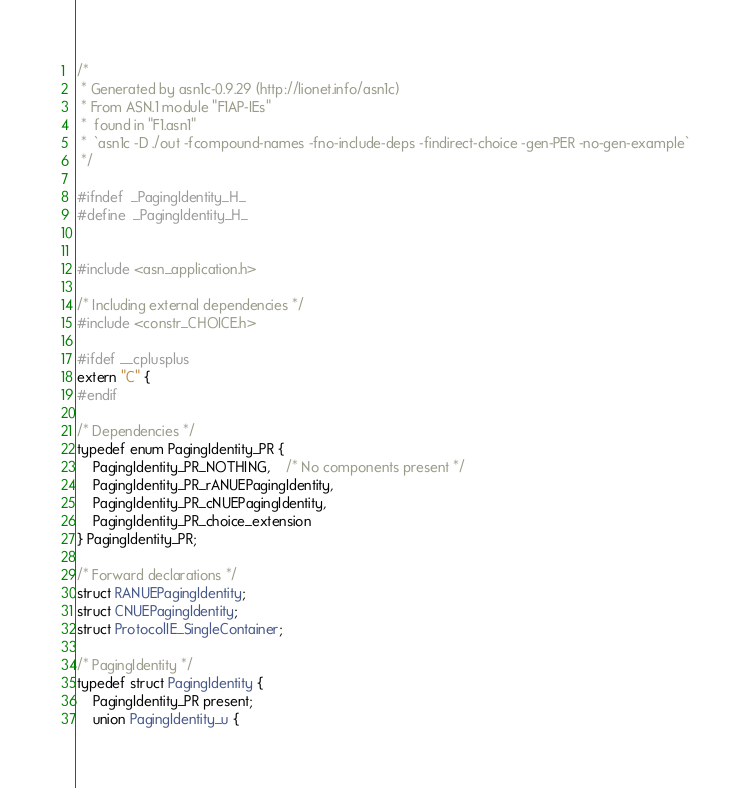Convert code to text. <code><loc_0><loc_0><loc_500><loc_500><_C_>/*
 * Generated by asn1c-0.9.29 (http://lionet.info/asn1c)
 * From ASN.1 module "F1AP-IEs"
 * 	found in "F1.asn1"
 * 	`asn1c -D ./out -fcompound-names -fno-include-deps -findirect-choice -gen-PER -no-gen-example`
 */

#ifndef	_PagingIdentity_H_
#define	_PagingIdentity_H_


#include <asn_application.h>

/* Including external dependencies */
#include <constr_CHOICE.h>

#ifdef __cplusplus
extern "C" {
#endif

/* Dependencies */
typedef enum PagingIdentity_PR {
	PagingIdentity_PR_NOTHING,	/* No components present */
	PagingIdentity_PR_rANUEPagingIdentity,
	PagingIdentity_PR_cNUEPagingIdentity,
	PagingIdentity_PR_choice_extension
} PagingIdentity_PR;

/* Forward declarations */
struct RANUEPagingIdentity;
struct CNUEPagingIdentity;
struct ProtocolIE_SingleContainer;

/* PagingIdentity */
typedef struct PagingIdentity {
	PagingIdentity_PR present;
	union PagingIdentity_u {</code> 